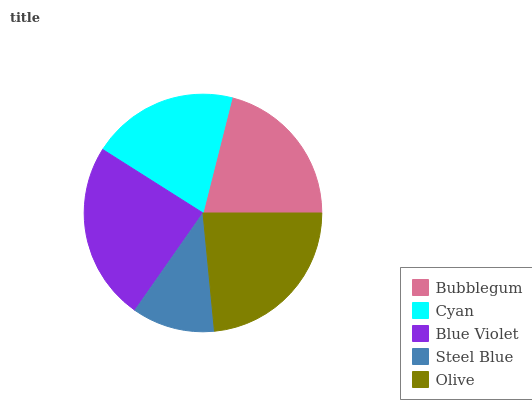Is Steel Blue the minimum?
Answer yes or no. Yes. Is Blue Violet the maximum?
Answer yes or no. Yes. Is Cyan the minimum?
Answer yes or no. No. Is Cyan the maximum?
Answer yes or no. No. Is Bubblegum greater than Cyan?
Answer yes or no. Yes. Is Cyan less than Bubblegum?
Answer yes or no. Yes. Is Cyan greater than Bubblegum?
Answer yes or no. No. Is Bubblegum less than Cyan?
Answer yes or no. No. Is Bubblegum the high median?
Answer yes or no. Yes. Is Bubblegum the low median?
Answer yes or no. Yes. Is Steel Blue the high median?
Answer yes or no. No. Is Blue Violet the low median?
Answer yes or no. No. 